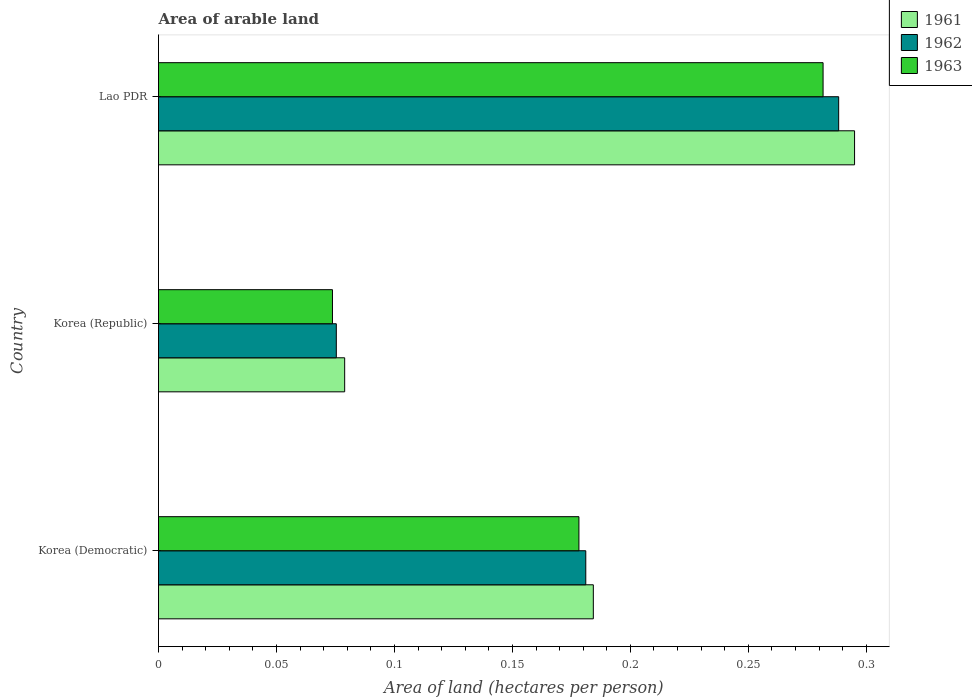How many different coloured bars are there?
Ensure brevity in your answer.  3. Are the number of bars per tick equal to the number of legend labels?
Make the answer very short. Yes. Are the number of bars on each tick of the Y-axis equal?
Your answer should be compact. Yes. How many bars are there on the 2nd tick from the bottom?
Keep it short and to the point. 3. What is the label of the 1st group of bars from the top?
Provide a succinct answer. Lao PDR. In how many cases, is the number of bars for a given country not equal to the number of legend labels?
Your answer should be compact. 0. What is the total arable land in 1961 in Korea (Republic)?
Keep it short and to the point. 0.08. Across all countries, what is the maximum total arable land in 1962?
Make the answer very short. 0.29. Across all countries, what is the minimum total arable land in 1961?
Offer a terse response. 0.08. In which country was the total arable land in 1961 maximum?
Offer a very short reply. Lao PDR. What is the total total arable land in 1962 in the graph?
Ensure brevity in your answer.  0.54. What is the difference between the total arable land in 1961 in Korea (Democratic) and that in Lao PDR?
Your answer should be very brief. -0.11. What is the difference between the total arable land in 1961 in Korea (Democratic) and the total arable land in 1962 in Korea (Republic)?
Your answer should be very brief. 0.11. What is the average total arable land in 1963 per country?
Your response must be concise. 0.18. What is the difference between the total arable land in 1962 and total arable land in 1961 in Korea (Democratic)?
Your answer should be very brief. -0. What is the ratio of the total arable land in 1962 in Korea (Democratic) to that in Lao PDR?
Your answer should be compact. 0.63. Is the difference between the total arable land in 1962 in Korea (Democratic) and Korea (Republic) greater than the difference between the total arable land in 1961 in Korea (Democratic) and Korea (Republic)?
Your response must be concise. Yes. What is the difference between the highest and the second highest total arable land in 1961?
Provide a succinct answer. 0.11. What is the difference between the highest and the lowest total arable land in 1963?
Offer a very short reply. 0.21. In how many countries, is the total arable land in 1963 greater than the average total arable land in 1963 taken over all countries?
Your answer should be compact. 2. What does the 2nd bar from the bottom in Korea (Democratic) represents?
Your answer should be very brief. 1962. Are all the bars in the graph horizontal?
Keep it short and to the point. Yes. What is the difference between two consecutive major ticks on the X-axis?
Offer a terse response. 0.05. How many legend labels are there?
Your response must be concise. 3. What is the title of the graph?
Your answer should be very brief. Area of arable land. Does "2007" appear as one of the legend labels in the graph?
Make the answer very short. No. What is the label or title of the X-axis?
Ensure brevity in your answer.  Area of land (hectares per person). What is the Area of land (hectares per person) of 1961 in Korea (Democratic)?
Keep it short and to the point. 0.18. What is the Area of land (hectares per person) of 1962 in Korea (Democratic)?
Offer a very short reply. 0.18. What is the Area of land (hectares per person) of 1963 in Korea (Democratic)?
Offer a very short reply. 0.18. What is the Area of land (hectares per person) in 1961 in Korea (Republic)?
Your response must be concise. 0.08. What is the Area of land (hectares per person) of 1962 in Korea (Republic)?
Ensure brevity in your answer.  0.08. What is the Area of land (hectares per person) in 1963 in Korea (Republic)?
Offer a terse response. 0.07. What is the Area of land (hectares per person) in 1961 in Lao PDR?
Provide a succinct answer. 0.3. What is the Area of land (hectares per person) of 1962 in Lao PDR?
Provide a short and direct response. 0.29. What is the Area of land (hectares per person) in 1963 in Lao PDR?
Give a very brief answer. 0.28. Across all countries, what is the maximum Area of land (hectares per person) in 1961?
Make the answer very short. 0.3. Across all countries, what is the maximum Area of land (hectares per person) in 1962?
Provide a short and direct response. 0.29. Across all countries, what is the maximum Area of land (hectares per person) in 1963?
Provide a short and direct response. 0.28. Across all countries, what is the minimum Area of land (hectares per person) in 1961?
Give a very brief answer. 0.08. Across all countries, what is the minimum Area of land (hectares per person) in 1962?
Give a very brief answer. 0.08. Across all countries, what is the minimum Area of land (hectares per person) of 1963?
Your answer should be compact. 0.07. What is the total Area of land (hectares per person) of 1961 in the graph?
Ensure brevity in your answer.  0.56. What is the total Area of land (hectares per person) in 1962 in the graph?
Your response must be concise. 0.54. What is the total Area of land (hectares per person) of 1963 in the graph?
Make the answer very short. 0.53. What is the difference between the Area of land (hectares per person) in 1961 in Korea (Democratic) and that in Korea (Republic)?
Ensure brevity in your answer.  0.11. What is the difference between the Area of land (hectares per person) of 1962 in Korea (Democratic) and that in Korea (Republic)?
Keep it short and to the point. 0.11. What is the difference between the Area of land (hectares per person) of 1963 in Korea (Democratic) and that in Korea (Republic)?
Your answer should be very brief. 0.1. What is the difference between the Area of land (hectares per person) of 1961 in Korea (Democratic) and that in Lao PDR?
Give a very brief answer. -0.11. What is the difference between the Area of land (hectares per person) in 1962 in Korea (Democratic) and that in Lao PDR?
Offer a terse response. -0.11. What is the difference between the Area of land (hectares per person) in 1963 in Korea (Democratic) and that in Lao PDR?
Offer a terse response. -0.1. What is the difference between the Area of land (hectares per person) of 1961 in Korea (Republic) and that in Lao PDR?
Keep it short and to the point. -0.22. What is the difference between the Area of land (hectares per person) in 1962 in Korea (Republic) and that in Lao PDR?
Give a very brief answer. -0.21. What is the difference between the Area of land (hectares per person) in 1963 in Korea (Republic) and that in Lao PDR?
Keep it short and to the point. -0.21. What is the difference between the Area of land (hectares per person) in 1961 in Korea (Democratic) and the Area of land (hectares per person) in 1962 in Korea (Republic)?
Your response must be concise. 0.11. What is the difference between the Area of land (hectares per person) in 1961 in Korea (Democratic) and the Area of land (hectares per person) in 1963 in Korea (Republic)?
Give a very brief answer. 0.11. What is the difference between the Area of land (hectares per person) in 1962 in Korea (Democratic) and the Area of land (hectares per person) in 1963 in Korea (Republic)?
Offer a very short reply. 0.11. What is the difference between the Area of land (hectares per person) in 1961 in Korea (Democratic) and the Area of land (hectares per person) in 1962 in Lao PDR?
Ensure brevity in your answer.  -0.1. What is the difference between the Area of land (hectares per person) in 1961 in Korea (Democratic) and the Area of land (hectares per person) in 1963 in Lao PDR?
Your answer should be very brief. -0.1. What is the difference between the Area of land (hectares per person) in 1962 in Korea (Democratic) and the Area of land (hectares per person) in 1963 in Lao PDR?
Offer a terse response. -0.1. What is the difference between the Area of land (hectares per person) of 1961 in Korea (Republic) and the Area of land (hectares per person) of 1962 in Lao PDR?
Your answer should be compact. -0.21. What is the difference between the Area of land (hectares per person) of 1961 in Korea (Republic) and the Area of land (hectares per person) of 1963 in Lao PDR?
Offer a terse response. -0.2. What is the difference between the Area of land (hectares per person) of 1962 in Korea (Republic) and the Area of land (hectares per person) of 1963 in Lao PDR?
Your answer should be compact. -0.21. What is the average Area of land (hectares per person) of 1961 per country?
Offer a very short reply. 0.19. What is the average Area of land (hectares per person) in 1962 per country?
Your answer should be very brief. 0.18. What is the average Area of land (hectares per person) in 1963 per country?
Make the answer very short. 0.18. What is the difference between the Area of land (hectares per person) of 1961 and Area of land (hectares per person) of 1962 in Korea (Democratic)?
Give a very brief answer. 0. What is the difference between the Area of land (hectares per person) of 1961 and Area of land (hectares per person) of 1963 in Korea (Democratic)?
Offer a terse response. 0.01. What is the difference between the Area of land (hectares per person) in 1962 and Area of land (hectares per person) in 1963 in Korea (Democratic)?
Your answer should be very brief. 0. What is the difference between the Area of land (hectares per person) of 1961 and Area of land (hectares per person) of 1962 in Korea (Republic)?
Ensure brevity in your answer.  0. What is the difference between the Area of land (hectares per person) in 1961 and Area of land (hectares per person) in 1963 in Korea (Republic)?
Ensure brevity in your answer.  0.01. What is the difference between the Area of land (hectares per person) of 1962 and Area of land (hectares per person) of 1963 in Korea (Republic)?
Give a very brief answer. 0. What is the difference between the Area of land (hectares per person) in 1961 and Area of land (hectares per person) in 1962 in Lao PDR?
Your answer should be very brief. 0.01. What is the difference between the Area of land (hectares per person) of 1961 and Area of land (hectares per person) of 1963 in Lao PDR?
Your answer should be very brief. 0.01. What is the difference between the Area of land (hectares per person) in 1962 and Area of land (hectares per person) in 1963 in Lao PDR?
Your answer should be very brief. 0.01. What is the ratio of the Area of land (hectares per person) in 1961 in Korea (Democratic) to that in Korea (Republic)?
Offer a very short reply. 2.34. What is the ratio of the Area of land (hectares per person) in 1962 in Korea (Democratic) to that in Korea (Republic)?
Give a very brief answer. 2.4. What is the ratio of the Area of land (hectares per person) of 1963 in Korea (Democratic) to that in Korea (Republic)?
Provide a short and direct response. 2.42. What is the ratio of the Area of land (hectares per person) of 1961 in Korea (Democratic) to that in Lao PDR?
Your answer should be very brief. 0.62. What is the ratio of the Area of land (hectares per person) of 1962 in Korea (Democratic) to that in Lao PDR?
Offer a very short reply. 0.63. What is the ratio of the Area of land (hectares per person) of 1963 in Korea (Democratic) to that in Lao PDR?
Offer a very short reply. 0.63. What is the ratio of the Area of land (hectares per person) in 1961 in Korea (Republic) to that in Lao PDR?
Offer a terse response. 0.27. What is the ratio of the Area of land (hectares per person) of 1962 in Korea (Republic) to that in Lao PDR?
Provide a succinct answer. 0.26. What is the ratio of the Area of land (hectares per person) in 1963 in Korea (Republic) to that in Lao PDR?
Your answer should be compact. 0.26. What is the difference between the highest and the second highest Area of land (hectares per person) in 1961?
Your answer should be compact. 0.11. What is the difference between the highest and the second highest Area of land (hectares per person) of 1962?
Provide a succinct answer. 0.11. What is the difference between the highest and the second highest Area of land (hectares per person) of 1963?
Ensure brevity in your answer.  0.1. What is the difference between the highest and the lowest Area of land (hectares per person) in 1961?
Give a very brief answer. 0.22. What is the difference between the highest and the lowest Area of land (hectares per person) in 1962?
Provide a succinct answer. 0.21. What is the difference between the highest and the lowest Area of land (hectares per person) of 1963?
Provide a short and direct response. 0.21. 